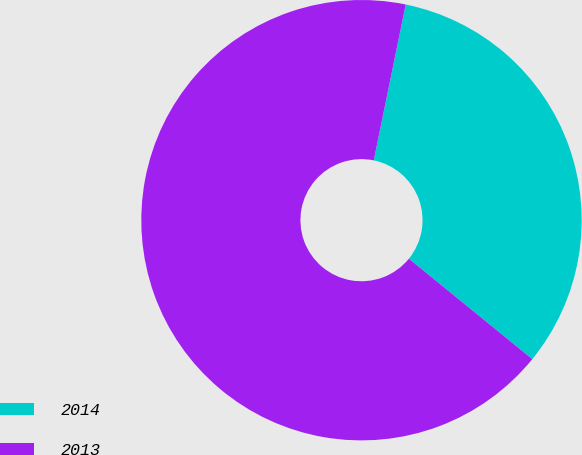<chart> <loc_0><loc_0><loc_500><loc_500><pie_chart><fcel>2014<fcel>2013<nl><fcel>32.65%<fcel>67.35%<nl></chart> 